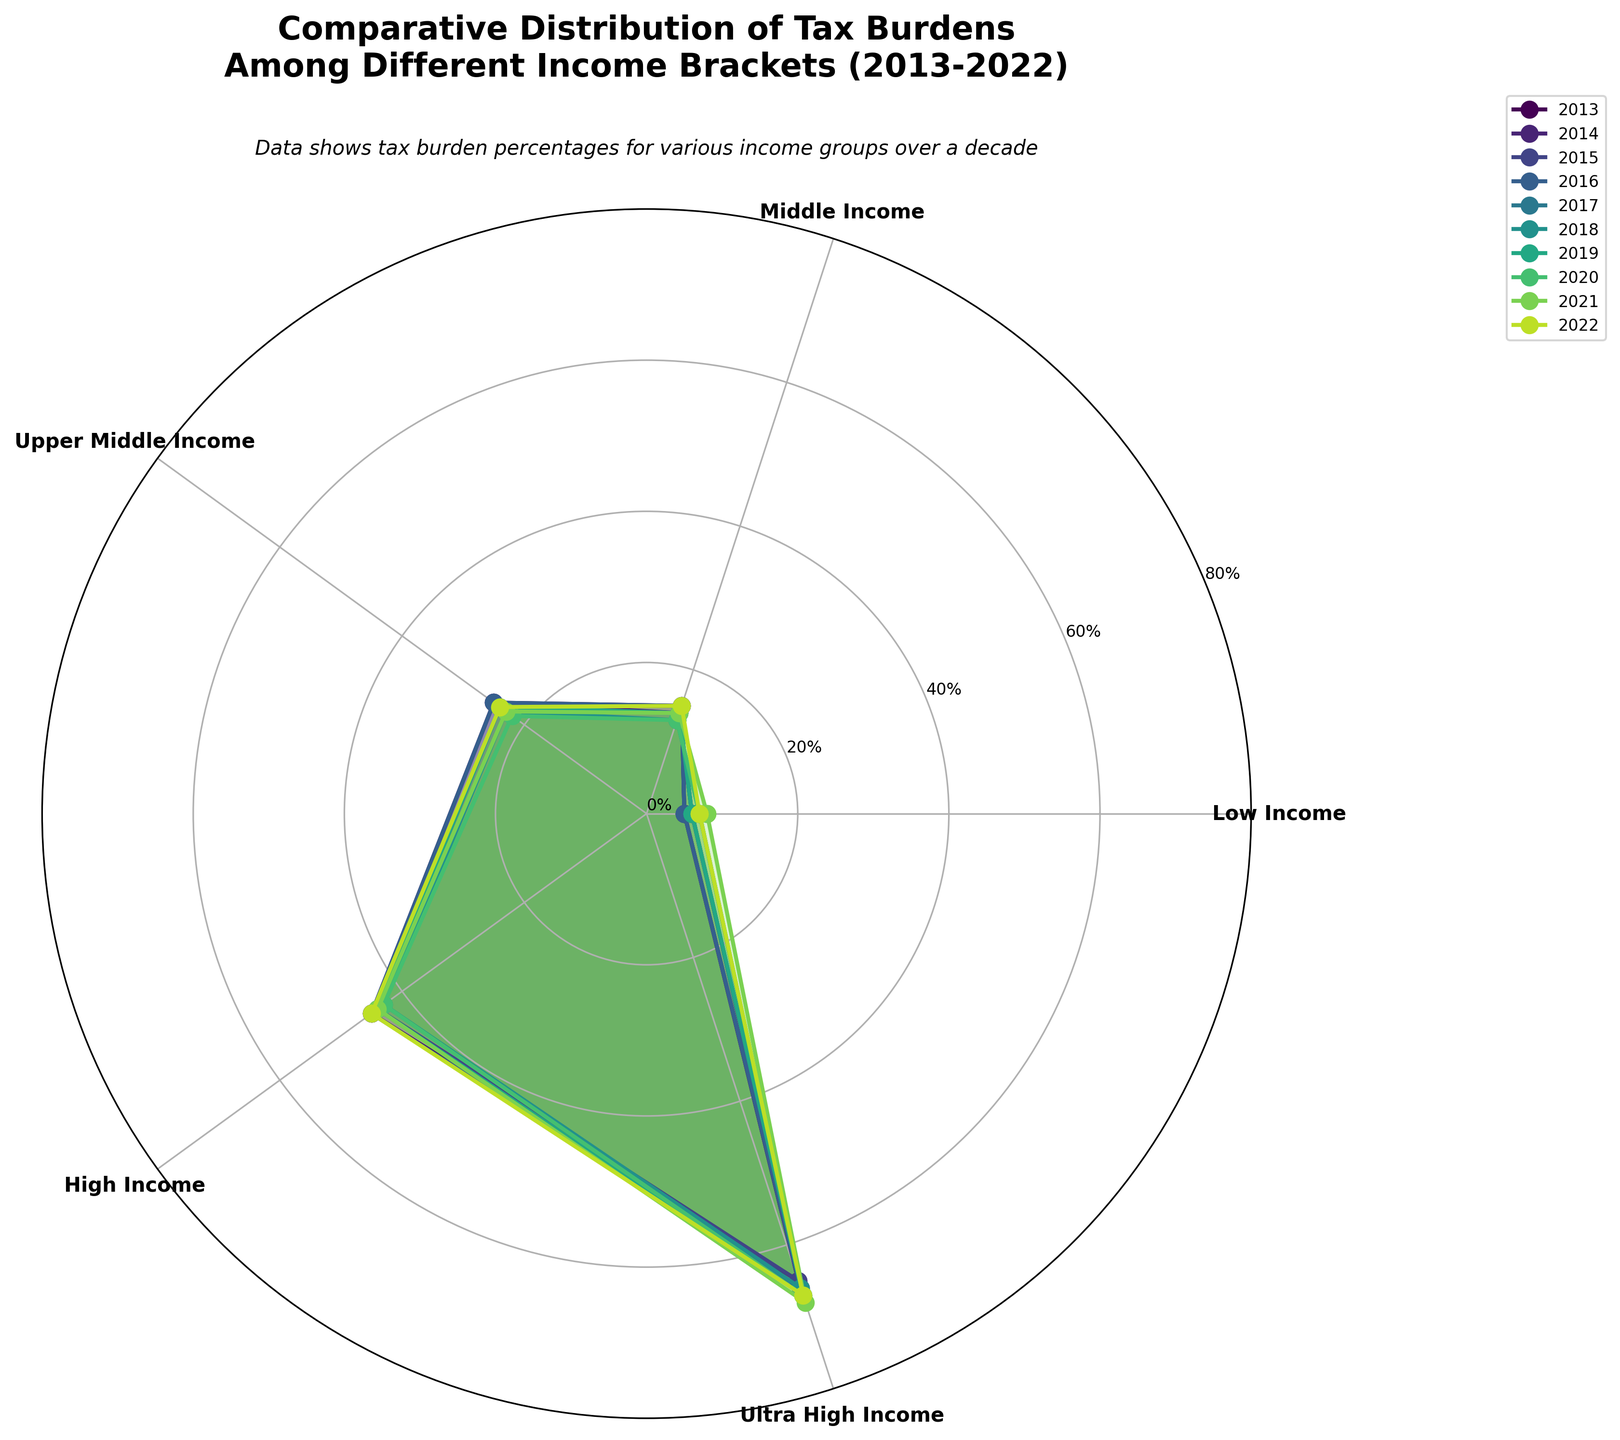What is the title of the plot? The title of the plot is found at the top and provides a summary of what the plot represents.
Answer: Comparative Distribution of Tax Burdens Among Different Income Brackets (2013-2022) Which income bracket had the highest tax burden in 2022? The plot shows different colored regions representing each year for each income bracket. For 2022, the outermost filled area can be observed.
Answer: Ultra High Income How did the tax burden for the "Low Income" bracket change from 2013 to 2022? Look at the position of the "Low Income" bracket across the years and compare 2013 and 2022. Notice the radial distance from the center for these years.
Answer: Increased from 5 to 7 Which group consistently has the highest tax burden over the decade? The outermost layer for each year, which marks the largest radial distance from the center, represents the highest tax burden. See which group this corresponds to.
Answer: Ultra High Income What general trend is observed for the "Middle Income" bracket over the years? Trace the progression of the values for the "Middle Income" bracket lines from 2013 to 2022 to identify any pattern or change.
Answer: The tax burden remains relatively stable In 2017, how did the tax burden for "High Income" compare to "Middle Income"? Compare the radial distance of "High Income" and "Middle Income" for the year 2017.
Answer: High Income was greater than Middle Income Which year had the lowest tax burden for the "Upper Middle Income" bracket? Identify the shortest radial distance for the "Upper Middle Income" line for each year on the plot.
Answer: 2020 What is the average tax burden for the "High Income" bracket across the decade? Calculate the average by summing the tax burden percentages for "High Income" from 2013 to 2022 and then dividing by 10.
Answer: 43.7 How did the tax burden for "Low Income" evolve between 2016 and 2018? Observe the evolution of the “Low Income” group by focusing on the points for 2016, 2017, and 2018 to see the trend over these years.
Answer: Increased from 5 to 7 Compare the tax burden for the "Ultra High Income" bracket between 2015 and 2021. Compare the radial distances corresponding to "Ultra High Income" for the years 2015 and 2021.
Answer: Increased from 65 to 68 